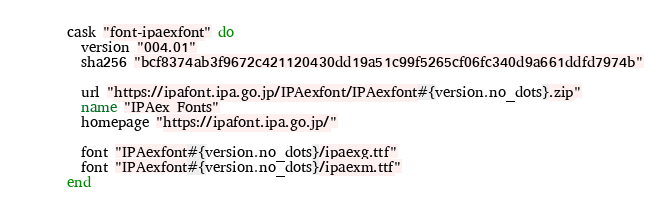<code> <loc_0><loc_0><loc_500><loc_500><_Ruby_>cask "font-ipaexfont" do
  version "004.01"
  sha256 "bcf8374ab3f9672c421120430dd19a51c99f5265cf06fc340d9a661ddfd7974b"

  url "https://ipafont.ipa.go.jp/IPAexfont/IPAexfont#{version.no_dots}.zip"
  name "IPAex Fonts"
  homepage "https://ipafont.ipa.go.jp/"

  font "IPAexfont#{version.no_dots}/ipaexg.ttf"
  font "IPAexfont#{version.no_dots}/ipaexm.ttf"
end
</code> 